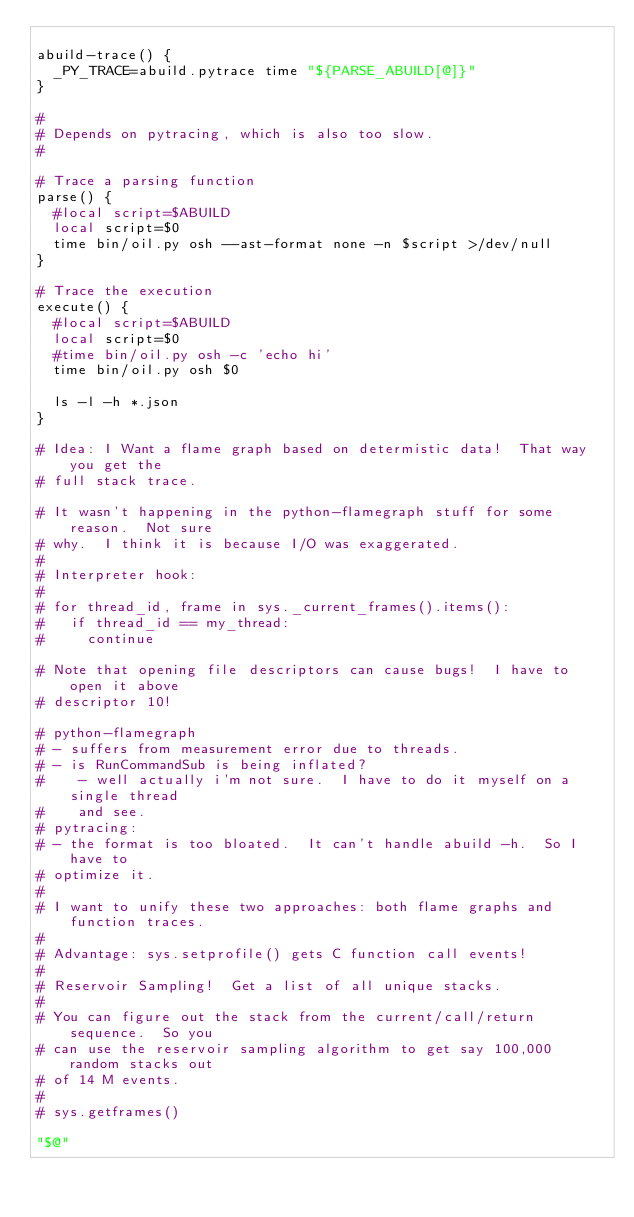Convert code to text. <code><loc_0><loc_0><loc_500><loc_500><_Bash_>
abuild-trace() {
  _PY_TRACE=abuild.pytrace time "${PARSE_ABUILD[@]}"
}

#
# Depends on pytracing, which is also too slow.
#

# Trace a parsing function
parse() {
  #local script=$ABUILD 
  local script=$0
  time bin/oil.py osh --ast-format none -n $script >/dev/null
}

# Trace the execution
execute() {
  #local script=$ABUILD 
  local script=$0
  #time bin/oil.py osh -c 'echo hi'
  time bin/oil.py osh $0

  ls -l -h *.json
}

# Idea: I Want a flame graph based on determistic data!  That way you get the
# full stack trace.

# It wasn't happening in the python-flamegraph stuff for some reason.  Not sure
# why.  I think it is because I/O was exaggerated.
# 
# Interpreter hook:
#
# for thread_id, frame in sys._current_frames().items():
#   if thread_id == my_thread:
#     continue

# Note that opening file descriptors can cause bugs!  I have to open it above
# descriptor 10!

# python-flamegraph
# - suffers from measurement error due to threads.  
# - is RunCommandSub is being inflated?
#    - well actually i'm not sure.  I have to do it myself on a single thread
#    and see.
# pytracing:
# - the format is too bloated.  It can't handle abuild -h.  So I have to
# optimize it.
#
# I want to unify these two approaches: both flame graphs and function traces.
#
# Advantage: sys.setprofile() gets C function call events!
#
# Reservoir Sampling!  Get a list of all unique stacks.
#
# You can figure out the stack from the current/call/return sequence.  So you
# can use the reservoir sampling algorithm to get say 100,000 random stacks out
# of 14 M events.
#
# sys.getframes()

"$@"
</code> 